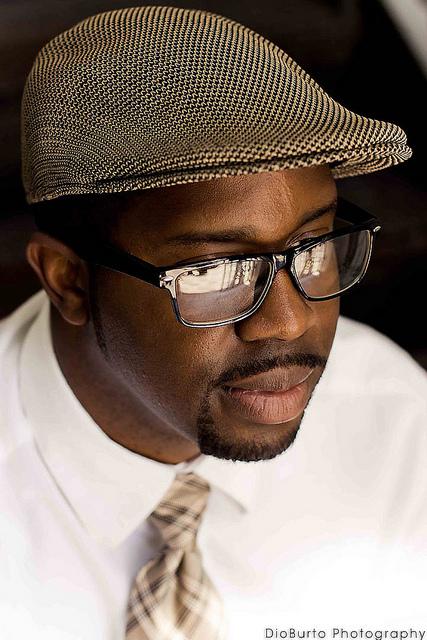What color is the man?
Concise answer only. Black. What color is the man's beard?
Short answer required. Black. How is the mouth of the man?
Quick response, please. Closed. Has the man recently trimmed his beard?
Be succinct. Yes. What is in the man's head?
Keep it brief. Hat. 